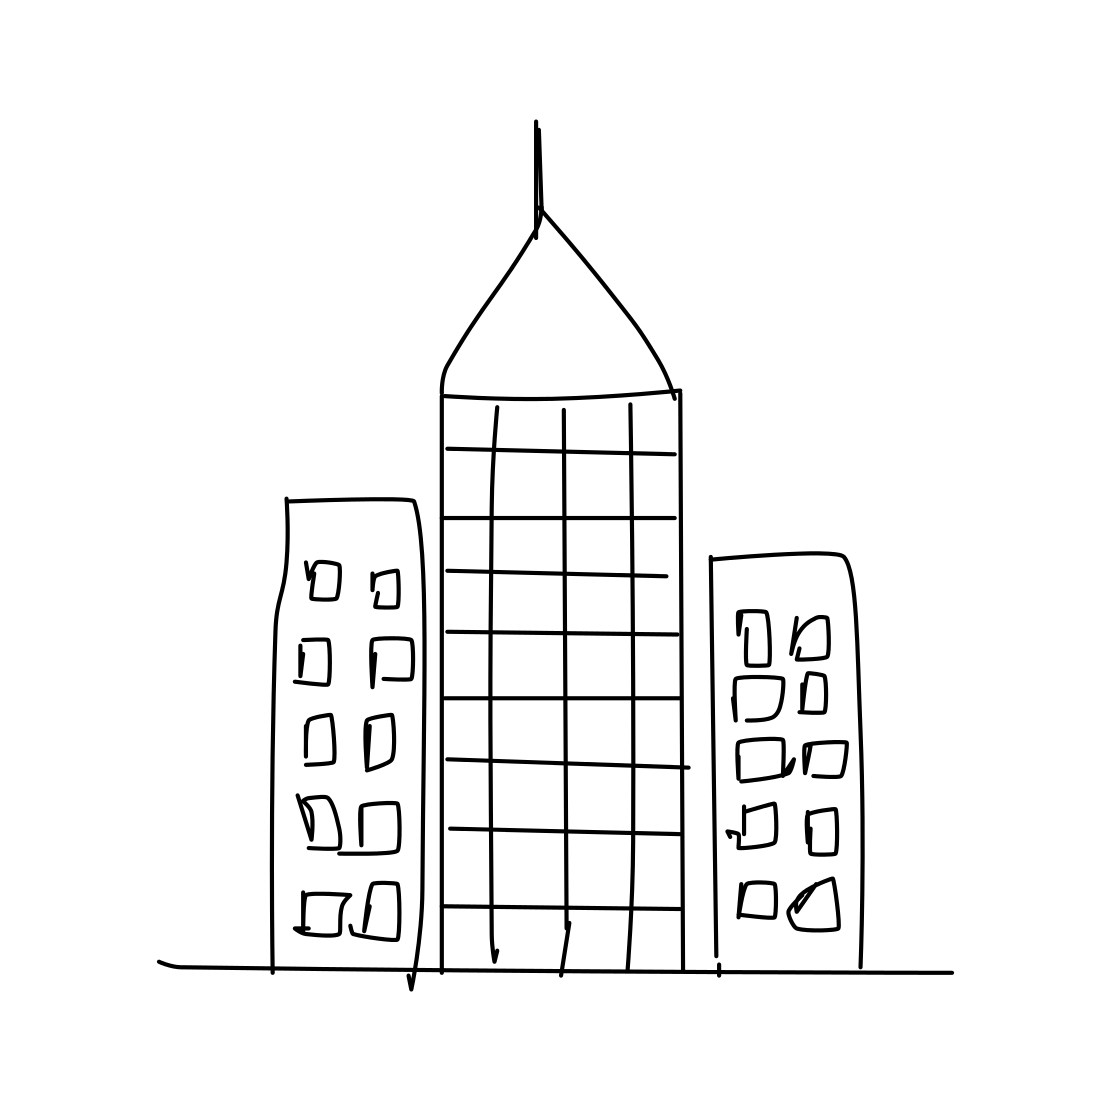In the scene, is an apple in it? No 